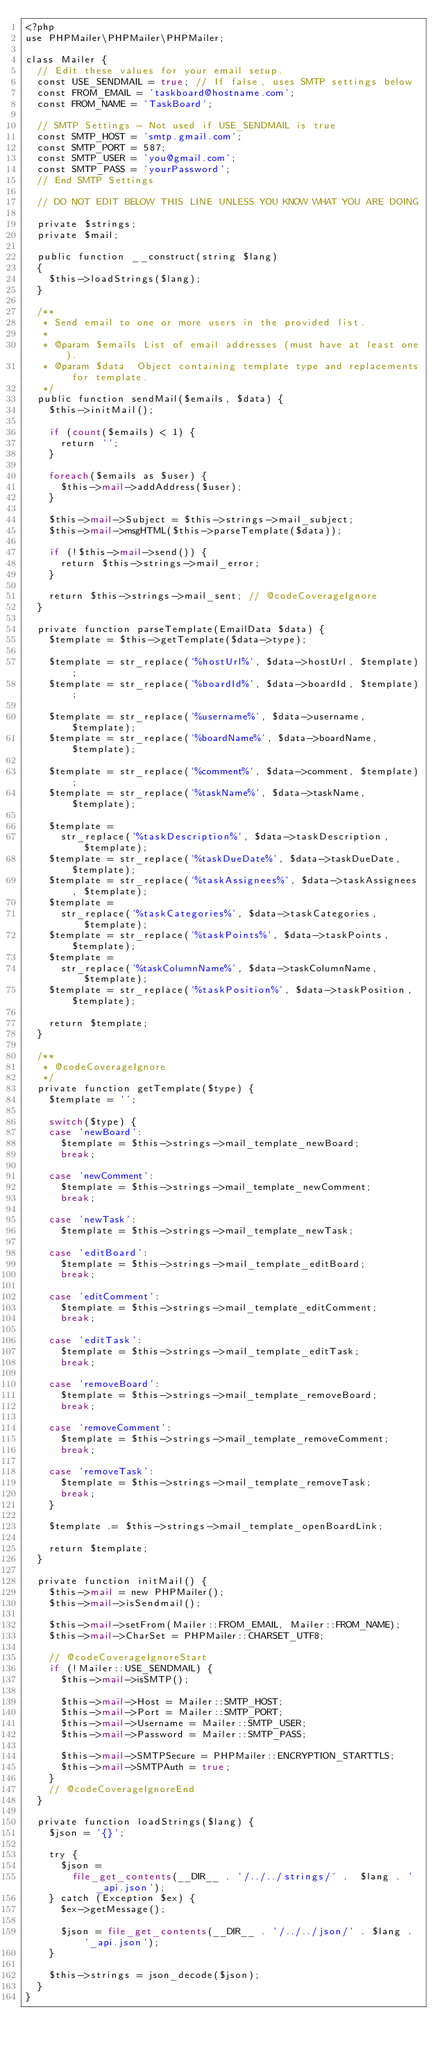<code> <loc_0><loc_0><loc_500><loc_500><_PHP_><?php
use PHPMailer\PHPMailer\PHPMailer;

class Mailer {
  // Edit these values for your email setup.
  const USE_SENDMAIL = true; // If false, uses SMTP settings below
  const FROM_EMAIL = 'taskboard@hostname.com';
  const FROM_NAME = 'TaskBoard';

  // SMTP Settings - Not used if USE_SENDMAIL is true
  const SMTP_HOST = 'smtp.gmail.com';
  const SMTP_PORT = 587;
  const SMTP_USER = 'you@gmail.com';
  const SMTP_PASS = 'yourPassword';
  // End SMTP Settings

  // DO NOT EDIT BELOW THIS LINE UNLESS YOU KNOW WHAT YOU ARE DOING

  private $strings;
  private $mail;

  public function __construct(string $lang)
  {
    $this->loadStrings($lang);
  }

  /**
   * Send email to one or more users in the provided list.
   *
   * @param $emails List of email addresses (must have at least one).
   * @param $data  Object containing template type and replacements for template.
   */
  public function sendMail($emails, $data) {
    $this->initMail();

    if (count($emails) < 1) {
      return '';
    }

    foreach($emails as $user) {
      $this->mail->addAddress($user);
    }

    $this->mail->Subject = $this->strings->mail_subject;
    $this->mail->msgHTML($this->parseTemplate($data));

    if (!$this->mail->send()) {
      return $this->strings->mail_error;
    }

    return $this->strings->mail_sent; // @codeCoverageIgnore
  }

  private function parseTemplate(EmailData $data) {
    $template = $this->getTemplate($data->type);

    $template = str_replace('%hostUrl%', $data->hostUrl, $template);
    $template = str_replace('%boardId%', $data->boardId, $template);

    $template = str_replace('%username%', $data->username, $template);
    $template = str_replace('%boardName%', $data->boardName, $template);

    $template = str_replace('%comment%', $data->comment, $template);
    $template = str_replace('%taskName%', $data->taskName, $template);

    $template =
      str_replace('%taskDescription%', $data->taskDescription, $template);
    $template = str_replace('%taskDueDate%', $data->taskDueDate, $template);
    $template = str_replace('%taskAssignees%', $data->taskAssignees, $template);
    $template =
      str_replace('%taskCategories%', $data->taskCategories, $template);
    $template = str_replace('%taskPoints%', $data->taskPoints, $template);
    $template =
      str_replace('%taskColumnName%', $data->taskColumnName, $template);
    $template = str_replace('%taskPosition%', $data->taskPosition, $template);

    return $template;
  }

  /**
   * @codeCoverageIgnore
   */
  private function getTemplate($type) {
    $template = '';

    switch($type) {
    case 'newBoard':
      $template = $this->strings->mail_template_newBoard;
      break;

    case 'newComment':
      $template = $this->strings->mail_template_newComment;
      break;

    case 'newTask':
      $template = $this->strings->mail_template_newTask;

    case 'editBoard':
      $template = $this->strings->mail_template_editBoard;
      break;

    case 'editComment':
      $template = $this->strings->mail_template_editComment;
      break;

    case 'editTask':
      $template = $this->strings->mail_template_editTask;
      break;

    case 'removeBoard':
      $template = $this->strings->mail_template_removeBoard;
      break;

    case 'removeComment':
      $template = $this->strings->mail_template_removeComment;
      break;

    case 'removeTask':
      $template = $this->strings->mail_template_removeTask;
      break;
    }

    $template .= $this->strings->mail_template_openBoardLink;

    return $template;
  }

  private function initMail() {
    $this->mail = new PHPMailer();
    $this->mail->isSendmail();

    $this->mail->setFrom(Mailer::FROM_EMAIL, Mailer::FROM_NAME);
    $this->mail->CharSet = PHPMailer::CHARSET_UTF8;

    // @codeCoverageIgnoreStart
    if (!Mailer::USE_SENDMAIL) {
      $this->mail->isSMTP();

      $this->mail->Host = Mailer::SMTP_HOST;
      $this->mail->Port = Mailer::SMTP_PORT;
      $this->mail->Username = Mailer::SMTP_USER;
      $this->mail->Password = Mailer::SMTP_PASS;

      $this->mail->SMTPSecure = PHPMailer::ENCRYPTION_STARTTLS;
      $this->mail->SMTPAuth = true;
    }
    // @codeCoverageIgnoreEnd
  }

  private function loadStrings($lang) {
    $json = '{}';

    try {
      $json =
        file_get_contents(__DIR__ . '/../../strings/' .  $lang . '_api.json');
    } catch (Exception $ex) {
      $ex->getMessage();

      $json = file_get_contents(__DIR__ . '/../../json/' . $lang . '_api.json');
    }

    $this->strings = json_decode($json);
  }
}
</code> 